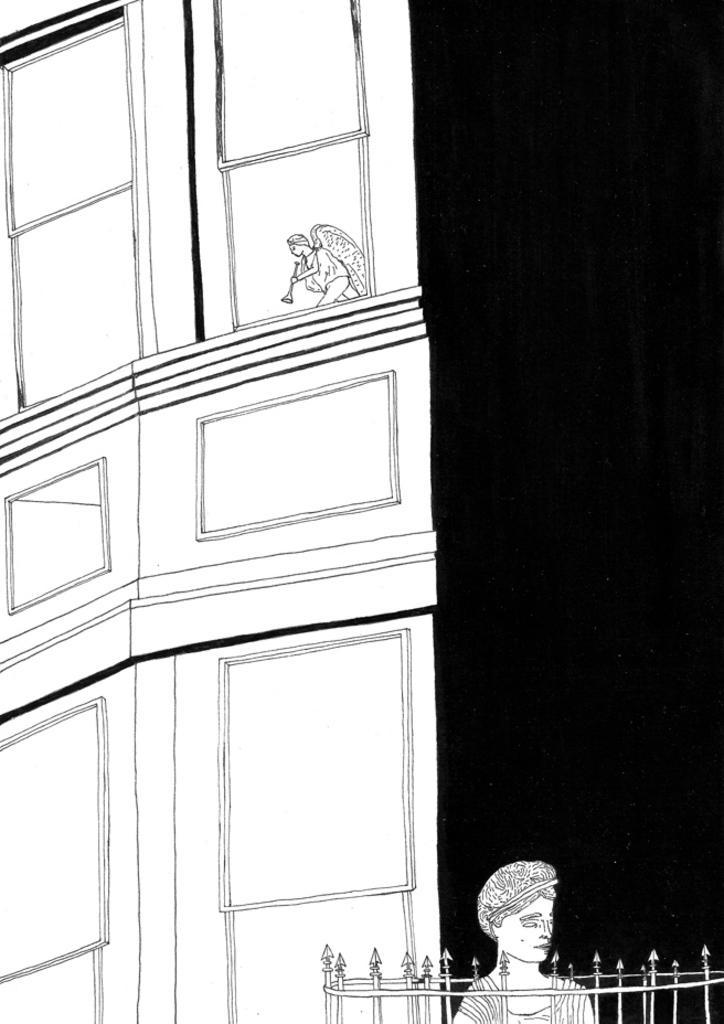In one or two sentences, can you explain what this image depicts? In the image in the center we can see one paper. On the paper,we can see one building,wall,fence and two persons were standing and holding some objects. And we can see black color border on the right side of the image. 